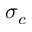<formula> <loc_0><loc_0><loc_500><loc_500>\sigma _ { c }</formula> 